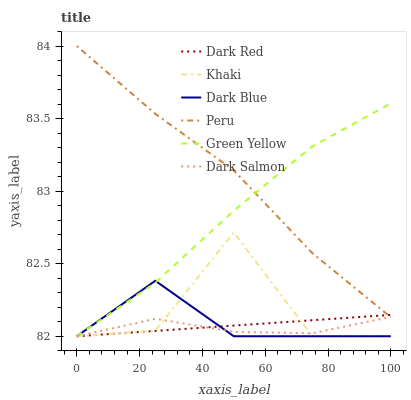Does Dark Salmon have the minimum area under the curve?
Answer yes or no. Yes. Does Peru have the maximum area under the curve?
Answer yes or no. Yes. Does Dark Red have the minimum area under the curve?
Answer yes or no. No. Does Dark Red have the maximum area under the curve?
Answer yes or no. No. Is Dark Red the smoothest?
Answer yes or no. Yes. Is Khaki the roughest?
Answer yes or no. Yes. Is Dark Salmon the smoothest?
Answer yes or no. No. Is Dark Salmon the roughest?
Answer yes or no. No. Does Khaki have the lowest value?
Answer yes or no. Yes. Does Peru have the lowest value?
Answer yes or no. No. Does Peru have the highest value?
Answer yes or no. Yes. Does Dark Red have the highest value?
Answer yes or no. No. Is Khaki less than Peru?
Answer yes or no. Yes. Is Peru greater than Khaki?
Answer yes or no. Yes. Does Khaki intersect Dark Salmon?
Answer yes or no. Yes. Is Khaki less than Dark Salmon?
Answer yes or no. No. Is Khaki greater than Dark Salmon?
Answer yes or no. No. Does Khaki intersect Peru?
Answer yes or no. No. 